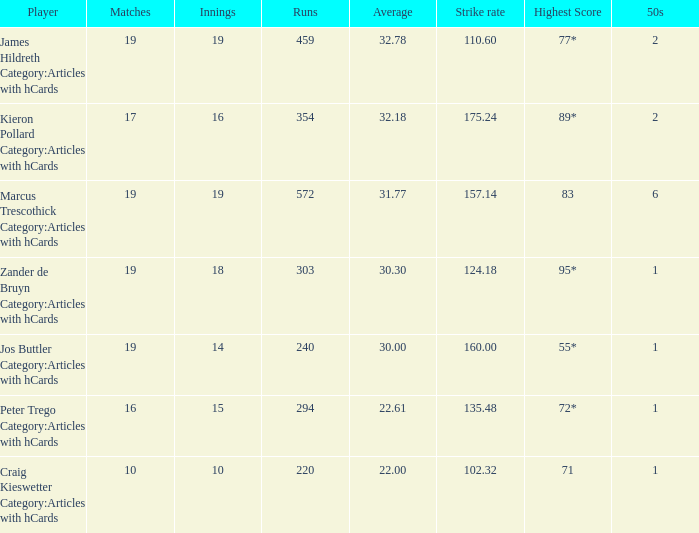How many innings does a player with an average of 2 15.0. 